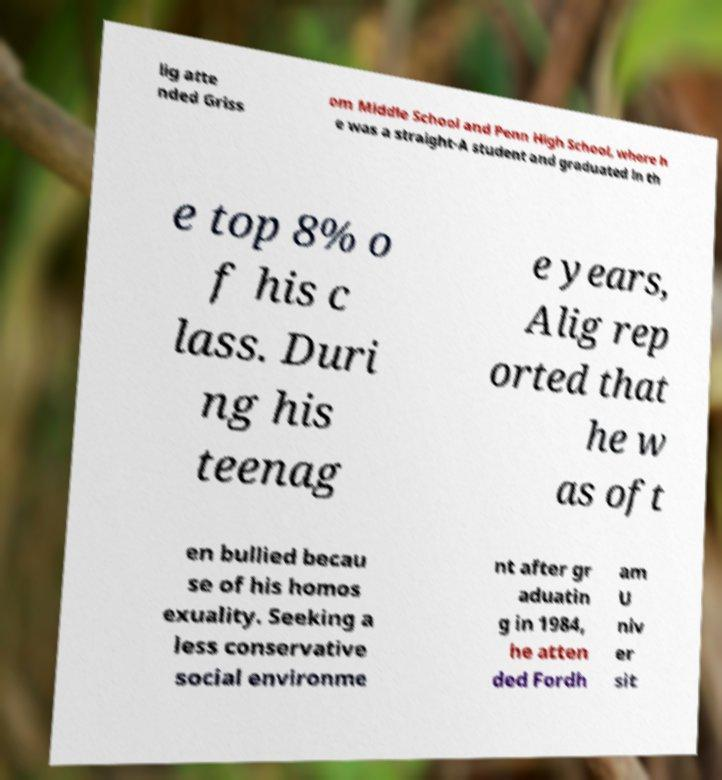Could you extract and type out the text from this image? lig atte nded Griss om Middle School and Penn High School, where h e was a straight-A student and graduated in th e top 8% o f his c lass. Duri ng his teenag e years, Alig rep orted that he w as oft en bullied becau se of his homos exuality. Seeking a less conservative social environme nt after gr aduatin g in 1984, he atten ded Fordh am U niv er sit 